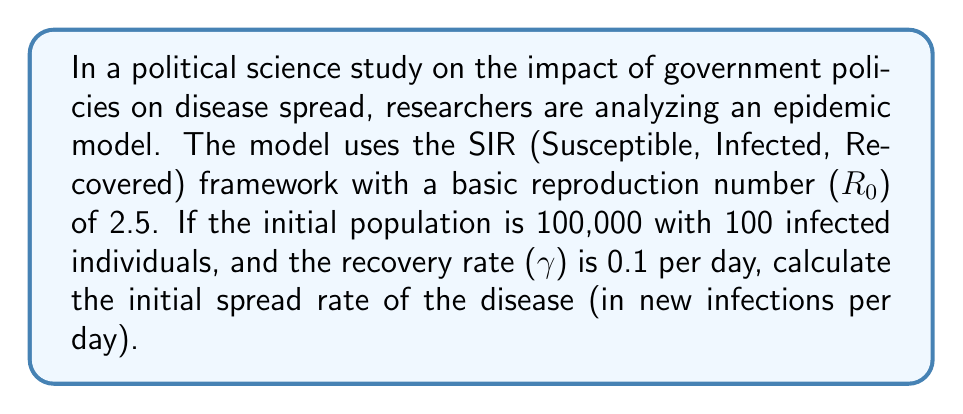Provide a solution to this math problem. To calculate the initial spread rate of the disease, we need to use the SIR model equations and the given information. Let's break it down step-by-step:

1. The SIR model is described by the following differential equations:

   $$\frac{dS}{dt} = -\beta SI$$
   $$\frac{dI}{dt} = \beta SI - \gamma I$$
   $$\frac{dR}{dt} = \gamma I$$

   Where:
   - $S$ is the number of susceptible individuals
   - $I$ is the number of infected individuals
   - $R$ is the number of recovered individuals
   - $\beta$ is the transmission rate
   - $\gamma$ is the recovery rate

2. We're given:
   - Total population: $N = 100,000$
   - Initial infected: $I_0 = 100$
   - Recovery rate: $\gamma = 0.1$ per day
   - Basic reproduction number: $R_0 = 2.5$

3. The basic reproduction number is defined as:

   $$R_0 = \frac{\beta}{\gamma}$$

4. We can calculate $\beta$ using $R_0$ and $\gamma$:

   $$\beta = R_0 \cdot \gamma = 2.5 \cdot 0.1 = 0.25$$

5. The initial number of susceptible individuals is:

   $$S_0 = N - I_0 = 100,000 - 100 = 99,900$$

6. The initial spread rate is given by $\frac{dI}{dt}$ at $t=0$:

   $$\frac{dI}{dt}\bigg|_{t=0} = \beta S_0 I_0 - \gamma I_0$$

7. Substituting the values:

   $$\frac{dI}{dt}\bigg|_{t=0} = (0.25 \cdot 99,900 \cdot 100) - (0.1 \cdot 100)$$
   $$\frac{dI}{dt}\bigg|_{t=0} = 2,497,500 - 10$$
   $$\frac{dI}{dt}\bigg|_{t=0} = 2,497,490$$

Therefore, the initial spread rate is 2,497,490 new infections per day.
Answer: 2,497,490 new infections per day 